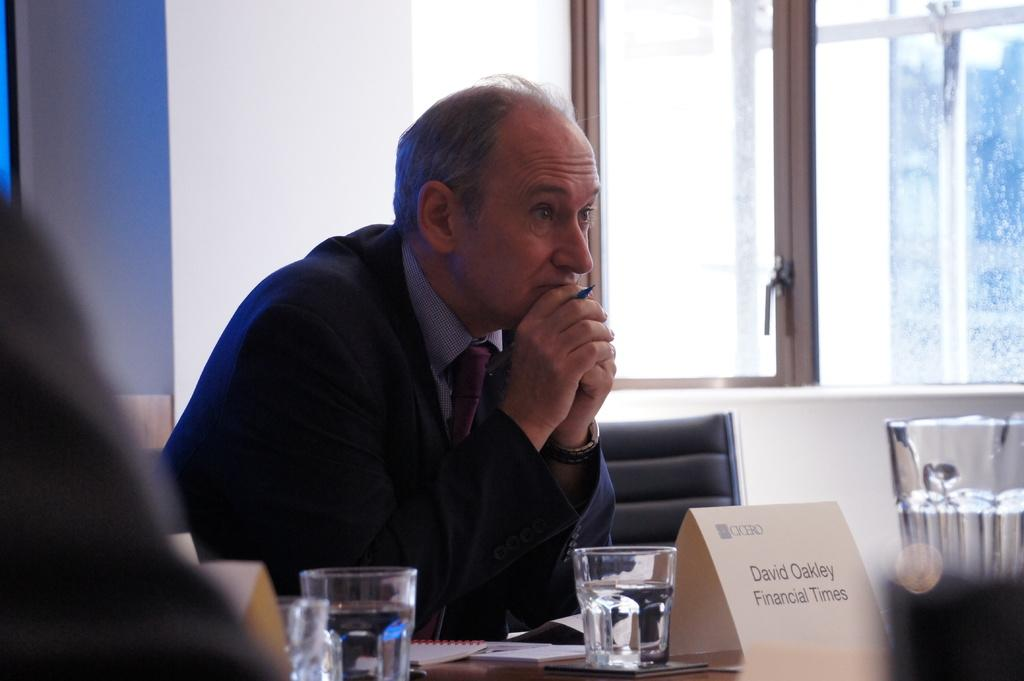Provide a one-sentence caption for the provided image. main in suite sitting at a table and card identifying him as david oakley from financial times. 